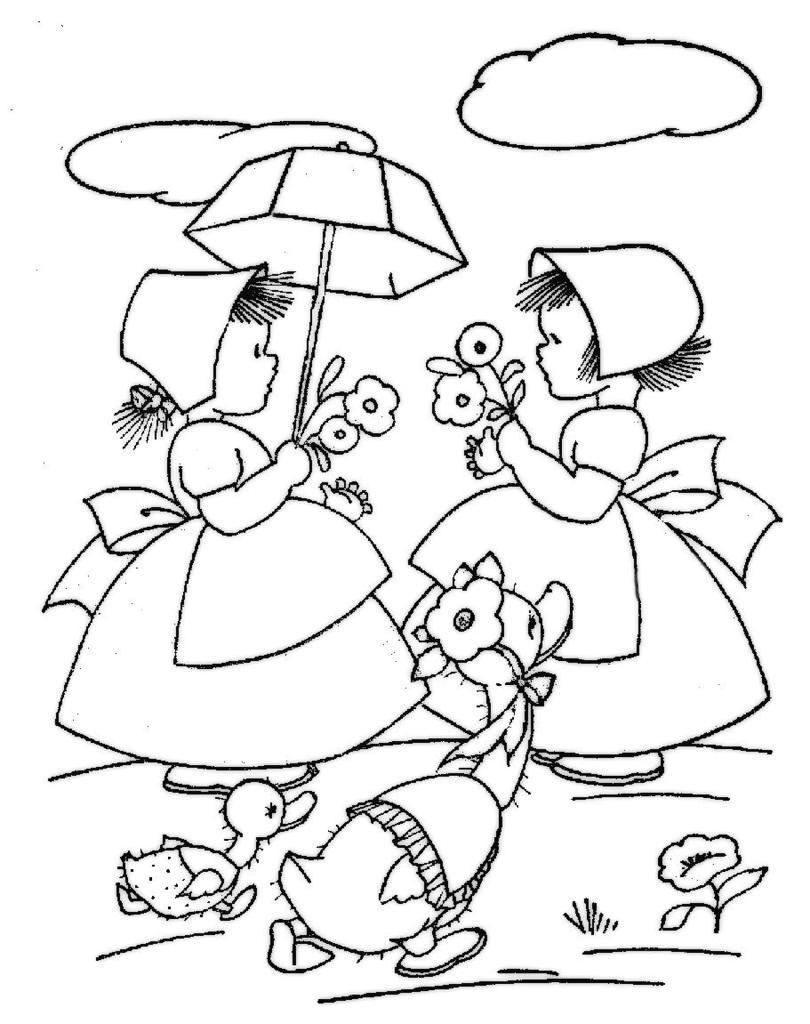Can you describe this image briefly? In this image, we can see an art contains depiction of persons and birds. 